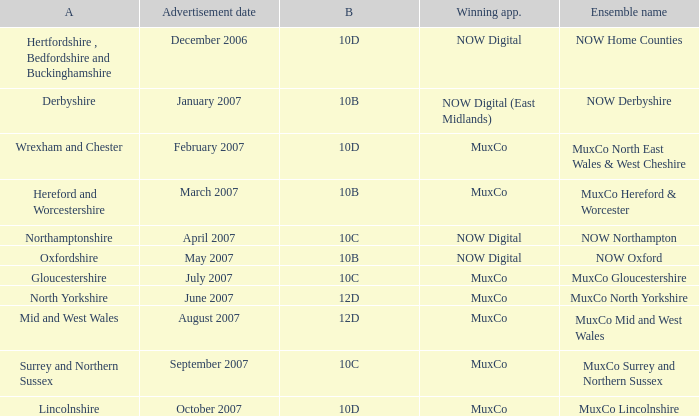In the derbyshire area, who has been awarded block 10b as the winning applicant? NOW Digital (East Midlands). Help me parse the entirety of this table. {'header': ['A', 'Advertisement date', 'B', 'Winning app.', 'Ensemble name'], 'rows': [['Hertfordshire , Bedfordshire and Buckinghamshire', 'December 2006', '10D', 'NOW Digital', 'NOW Home Counties'], ['Derbyshire', 'January 2007', '10B', 'NOW Digital (East Midlands)', 'NOW Derbyshire'], ['Wrexham and Chester', 'February 2007', '10D', 'MuxCo', 'MuxCo North East Wales & West Cheshire'], ['Hereford and Worcestershire', 'March 2007', '10B', 'MuxCo', 'MuxCo Hereford & Worcester'], ['Northamptonshire', 'April 2007', '10C', 'NOW Digital', 'NOW Northampton'], ['Oxfordshire', 'May 2007', '10B', 'NOW Digital', 'NOW Oxford'], ['Gloucestershire', 'July 2007', '10C', 'MuxCo', 'MuxCo Gloucestershire'], ['North Yorkshire', 'June 2007', '12D', 'MuxCo', 'MuxCo North Yorkshire'], ['Mid and West Wales', 'August 2007', '12D', 'MuxCo', 'MuxCo Mid and West Wales'], ['Surrey and Northern Sussex', 'September 2007', '10C', 'MuxCo', 'MuxCo Surrey and Northern Sussex'], ['Lincolnshire', 'October 2007', '10D', 'MuxCo', 'MuxCo Lincolnshire']]} 